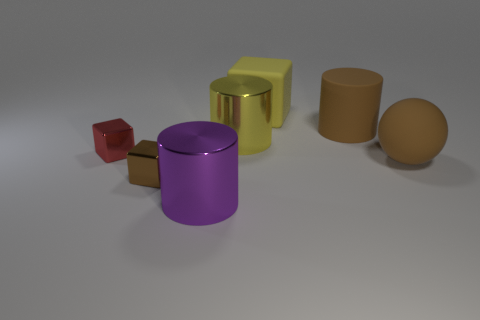Subtract all large matte blocks. How many blocks are left? 2 Add 2 small purple matte objects. How many objects exist? 9 Subtract all red cubes. How many cubes are left? 2 Subtract 2 cylinders. How many cylinders are left? 1 Subtract all blocks. How many objects are left? 4 Subtract all red cylinders. Subtract all blue spheres. How many cylinders are left? 3 Subtract all red cylinders. How many brown cubes are left? 1 Add 3 small red cubes. How many small red cubes exist? 4 Subtract 0 cyan cylinders. How many objects are left? 7 Subtract all big yellow metal cylinders. Subtract all large brown objects. How many objects are left? 4 